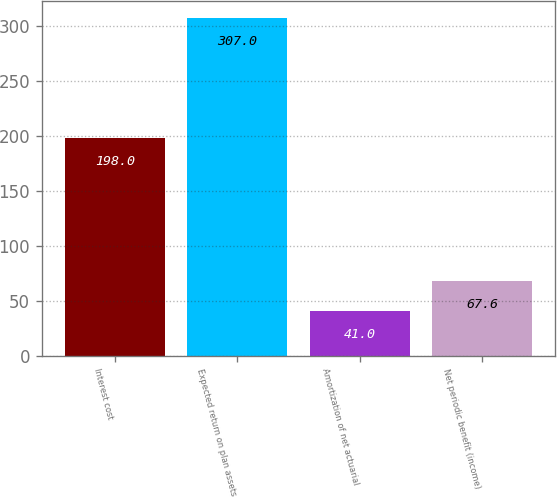<chart> <loc_0><loc_0><loc_500><loc_500><bar_chart><fcel>Interest cost<fcel>Expected return on plan assets<fcel>Amortization of net actuarial<fcel>Net periodic benefit (income)<nl><fcel>198<fcel>307<fcel>41<fcel>67.6<nl></chart> 